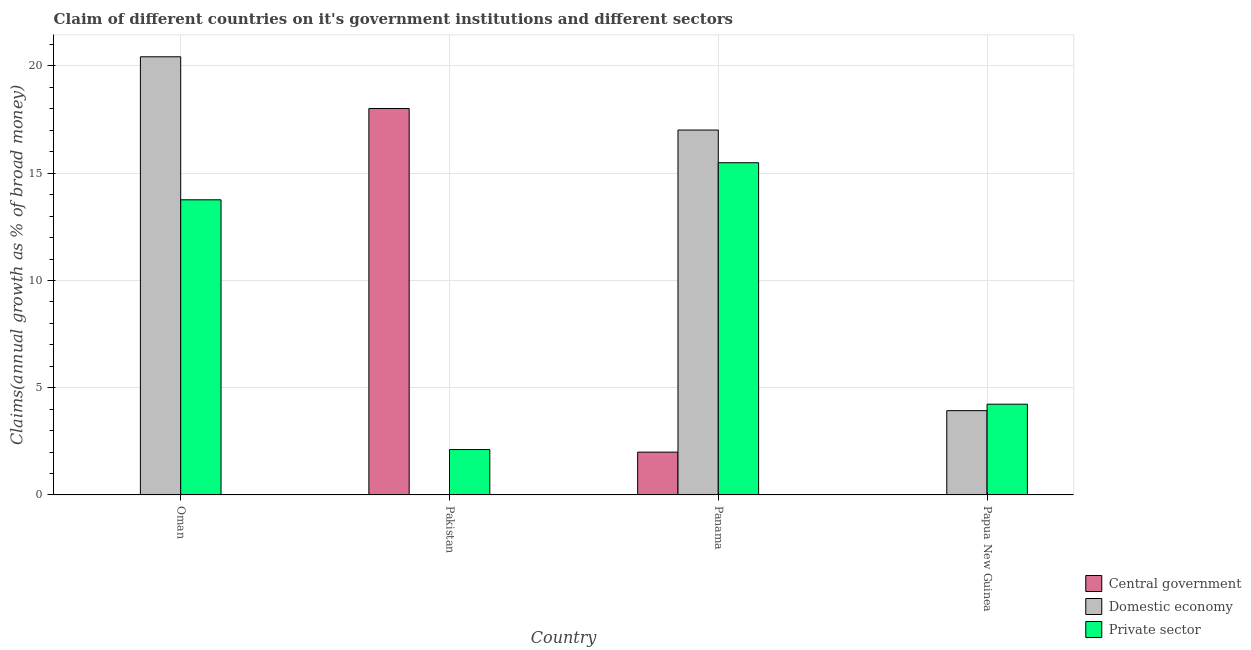Are the number of bars per tick equal to the number of legend labels?
Your response must be concise. No. Are the number of bars on each tick of the X-axis equal?
Keep it short and to the point. No. How many bars are there on the 4th tick from the left?
Offer a terse response. 2. How many bars are there on the 4th tick from the right?
Provide a short and direct response. 2. What is the label of the 1st group of bars from the left?
Make the answer very short. Oman. In how many cases, is the number of bars for a given country not equal to the number of legend labels?
Ensure brevity in your answer.  3. Across all countries, what is the maximum percentage of claim on the central government?
Keep it short and to the point. 18.02. In which country was the percentage of claim on the domestic economy maximum?
Offer a very short reply. Oman. What is the total percentage of claim on the central government in the graph?
Provide a succinct answer. 20.01. What is the difference between the percentage of claim on the domestic economy in Oman and that in Panama?
Offer a terse response. 3.42. What is the difference between the percentage of claim on the private sector in Oman and the percentage of claim on the domestic economy in Pakistan?
Your response must be concise. 13.76. What is the average percentage of claim on the private sector per country?
Keep it short and to the point. 8.9. What is the difference between the percentage of claim on the private sector and percentage of claim on the central government in Pakistan?
Keep it short and to the point. -15.9. In how many countries, is the percentage of claim on the central government greater than 11 %?
Provide a succinct answer. 1. What is the ratio of the percentage of claim on the private sector in Oman to that in Panama?
Keep it short and to the point. 0.89. What is the difference between the highest and the second highest percentage of claim on the private sector?
Ensure brevity in your answer.  1.73. What is the difference between the highest and the lowest percentage of claim on the central government?
Make the answer very short. 18.02. In how many countries, is the percentage of claim on the private sector greater than the average percentage of claim on the private sector taken over all countries?
Offer a very short reply. 2. Is it the case that in every country, the sum of the percentage of claim on the central government and percentage of claim on the domestic economy is greater than the percentage of claim on the private sector?
Offer a very short reply. No. How many bars are there?
Your response must be concise. 9. Are all the bars in the graph horizontal?
Your response must be concise. No. How many countries are there in the graph?
Make the answer very short. 4. Are the values on the major ticks of Y-axis written in scientific E-notation?
Provide a short and direct response. No. Does the graph contain any zero values?
Your answer should be compact. Yes. Does the graph contain grids?
Keep it short and to the point. Yes. What is the title of the graph?
Your answer should be compact. Claim of different countries on it's government institutions and different sectors. Does "Communicable diseases" appear as one of the legend labels in the graph?
Give a very brief answer. No. What is the label or title of the X-axis?
Your response must be concise. Country. What is the label or title of the Y-axis?
Give a very brief answer. Claims(annual growth as % of broad money). What is the Claims(annual growth as % of broad money) in Domestic economy in Oman?
Your response must be concise. 20.43. What is the Claims(annual growth as % of broad money) in Private sector in Oman?
Give a very brief answer. 13.76. What is the Claims(annual growth as % of broad money) in Central government in Pakistan?
Provide a succinct answer. 18.02. What is the Claims(annual growth as % of broad money) in Private sector in Pakistan?
Ensure brevity in your answer.  2.12. What is the Claims(annual growth as % of broad money) in Central government in Panama?
Provide a short and direct response. 2. What is the Claims(annual growth as % of broad money) of Domestic economy in Panama?
Your response must be concise. 17.01. What is the Claims(annual growth as % of broad money) in Private sector in Panama?
Give a very brief answer. 15.49. What is the Claims(annual growth as % of broad money) in Domestic economy in Papua New Guinea?
Your answer should be very brief. 3.93. What is the Claims(annual growth as % of broad money) in Private sector in Papua New Guinea?
Ensure brevity in your answer.  4.23. Across all countries, what is the maximum Claims(annual growth as % of broad money) in Central government?
Ensure brevity in your answer.  18.02. Across all countries, what is the maximum Claims(annual growth as % of broad money) of Domestic economy?
Give a very brief answer. 20.43. Across all countries, what is the maximum Claims(annual growth as % of broad money) of Private sector?
Make the answer very short. 15.49. Across all countries, what is the minimum Claims(annual growth as % of broad money) of Domestic economy?
Your response must be concise. 0. Across all countries, what is the minimum Claims(annual growth as % of broad money) in Private sector?
Give a very brief answer. 2.12. What is the total Claims(annual growth as % of broad money) of Central government in the graph?
Provide a short and direct response. 20.01. What is the total Claims(annual growth as % of broad money) of Domestic economy in the graph?
Give a very brief answer. 41.37. What is the total Claims(annual growth as % of broad money) of Private sector in the graph?
Offer a very short reply. 35.59. What is the difference between the Claims(annual growth as % of broad money) in Private sector in Oman and that in Pakistan?
Offer a terse response. 11.64. What is the difference between the Claims(annual growth as % of broad money) in Domestic economy in Oman and that in Panama?
Offer a terse response. 3.42. What is the difference between the Claims(annual growth as % of broad money) in Private sector in Oman and that in Panama?
Ensure brevity in your answer.  -1.73. What is the difference between the Claims(annual growth as % of broad money) in Domestic economy in Oman and that in Papua New Guinea?
Give a very brief answer. 16.5. What is the difference between the Claims(annual growth as % of broad money) in Private sector in Oman and that in Papua New Guinea?
Your answer should be compact. 9.53. What is the difference between the Claims(annual growth as % of broad money) in Central government in Pakistan and that in Panama?
Make the answer very short. 16.02. What is the difference between the Claims(annual growth as % of broad money) in Private sector in Pakistan and that in Panama?
Keep it short and to the point. -13.37. What is the difference between the Claims(annual growth as % of broad money) in Private sector in Pakistan and that in Papua New Guinea?
Give a very brief answer. -2.11. What is the difference between the Claims(annual growth as % of broad money) in Domestic economy in Panama and that in Papua New Guinea?
Offer a terse response. 13.08. What is the difference between the Claims(annual growth as % of broad money) in Private sector in Panama and that in Papua New Guinea?
Your answer should be compact. 11.26. What is the difference between the Claims(annual growth as % of broad money) of Domestic economy in Oman and the Claims(annual growth as % of broad money) of Private sector in Pakistan?
Give a very brief answer. 18.31. What is the difference between the Claims(annual growth as % of broad money) of Domestic economy in Oman and the Claims(annual growth as % of broad money) of Private sector in Panama?
Your answer should be very brief. 4.94. What is the difference between the Claims(annual growth as % of broad money) in Domestic economy in Oman and the Claims(annual growth as % of broad money) in Private sector in Papua New Guinea?
Your answer should be very brief. 16.2. What is the difference between the Claims(annual growth as % of broad money) in Central government in Pakistan and the Claims(annual growth as % of broad money) in Private sector in Panama?
Offer a very short reply. 2.53. What is the difference between the Claims(annual growth as % of broad money) of Central government in Pakistan and the Claims(annual growth as % of broad money) of Domestic economy in Papua New Guinea?
Provide a short and direct response. 14.09. What is the difference between the Claims(annual growth as % of broad money) in Central government in Pakistan and the Claims(annual growth as % of broad money) in Private sector in Papua New Guinea?
Give a very brief answer. 13.79. What is the difference between the Claims(annual growth as % of broad money) of Central government in Panama and the Claims(annual growth as % of broad money) of Domestic economy in Papua New Guinea?
Your answer should be compact. -1.93. What is the difference between the Claims(annual growth as % of broad money) in Central government in Panama and the Claims(annual growth as % of broad money) in Private sector in Papua New Guinea?
Provide a succinct answer. -2.23. What is the difference between the Claims(annual growth as % of broad money) of Domestic economy in Panama and the Claims(annual growth as % of broad money) of Private sector in Papua New Guinea?
Offer a very short reply. 12.78. What is the average Claims(annual growth as % of broad money) in Central government per country?
Ensure brevity in your answer.  5. What is the average Claims(annual growth as % of broad money) in Domestic economy per country?
Your answer should be compact. 10.34. What is the average Claims(annual growth as % of broad money) of Private sector per country?
Your answer should be compact. 8.9. What is the difference between the Claims(annual growth as % of broad money) in Domestic economy and Claims(annual growth as % of broad money) in Private sector in Oman?
Offer a very short reply. 6.67. What is the difference between the Claims(annual growth as % of broad money) of Central government and Claims(annual growth as % of broad money) of Private sector in Pakistan?
Offer a very short reply. 15.9. What is the difference between the Claims(annual growth as % of broad money) of Central government and Claims(annual growth as % of broad money) of Domestic economy in Panama?
Keep it short and to the point. -15.02. What is the difference between the Claims(annual growth as % of broad money) in Central government and Claims(annual growth as % of broad money) in Private sector in Panama?
Provide a succinct answer. -13.49. What is the difference between the Claims(annual growth as % of broad money) in Domestic economy and Claims(annual growth as % of broad money) in Private sector in Panama?
Provide a succinct answer. 1.52. What is the difference between the Claims(annual growth as % of broad money) in Domestic economy and Claims(annual growth as % of broad money) in Private sector in Papua New Guinea?
Make the answer very short. -0.3. What is the ratio of the Claims(annual growth as % of broad money) of Private sector in Oman to that in Pakistan?
Give a very brief answer. 6.5. What is the ratio of the Claims(annual growth as % of broad money) of Domestic economy in Oman to that in Panama?
Offer a very short reply. 1.2. What is the ratio of the Claims(annual growth as % of broad money) of Private sector in Oman to that in Panama?
Your answer should be compact. 0.89. What is the ratio of the Claims(annual growth as % of broad money) in Domestic economy in Oman to that in Papua New Guinea?
Your answer should be very brief. 5.2. What is the ratio of the Claims(annual growth as % of broad money) of Private sector in Oman to that in Papua New Guinea?
Ensure brevity in your answer.  3.25. What is the ratio of the Claims(annual growth as % of broad money) in Central government in Pakistan to that in Panama?
Make the answer very short. 9.03. What is the ratio of the Claims(annual growth as % of broad money) of Private sector in Pakistan to that in Panama?
Provide a short and direct response. 0.14. What is the ratio of the Claims(annual growth as % of broad money) in Private sector in Pakistan to that in Papua New Guinea?
Ensure brevity in your answer.  0.5. What is the ratio of the Claims(annual growth as % of broad money) of Domestic economy in Panama to that in Papua New Guinea?
Give a very brief answer. 4.33. What is the ratio of the Claims(annual growth as % of broad money) of Private sector in Panama to that in Papua New Guinea?
Your answer should be very brief. 3.66. What is the difference between the highest and the second highest Claims(annual growth as % of broad money) of Domestic economy?
Offer a very short reply. 3.42. What is the difference between the highest and the second highest Claims(annual growth as % of broad money) in Private sector?
Provide a short and direct response. 1.73. What is the difference between the highest and the lowest Claims(annual growth as % of broad money) of Central government?
Your answer should be compact. 18.02. What is the difference between the highest and the lowest Claims(annual growth as % of broad money) of Domestic economy?
Make the answer very short. 20.43. What is the difference between the highest and the lowest Claims(annual growth as % of broad money) in Private sector?
Your response must be concise. 13.37. 